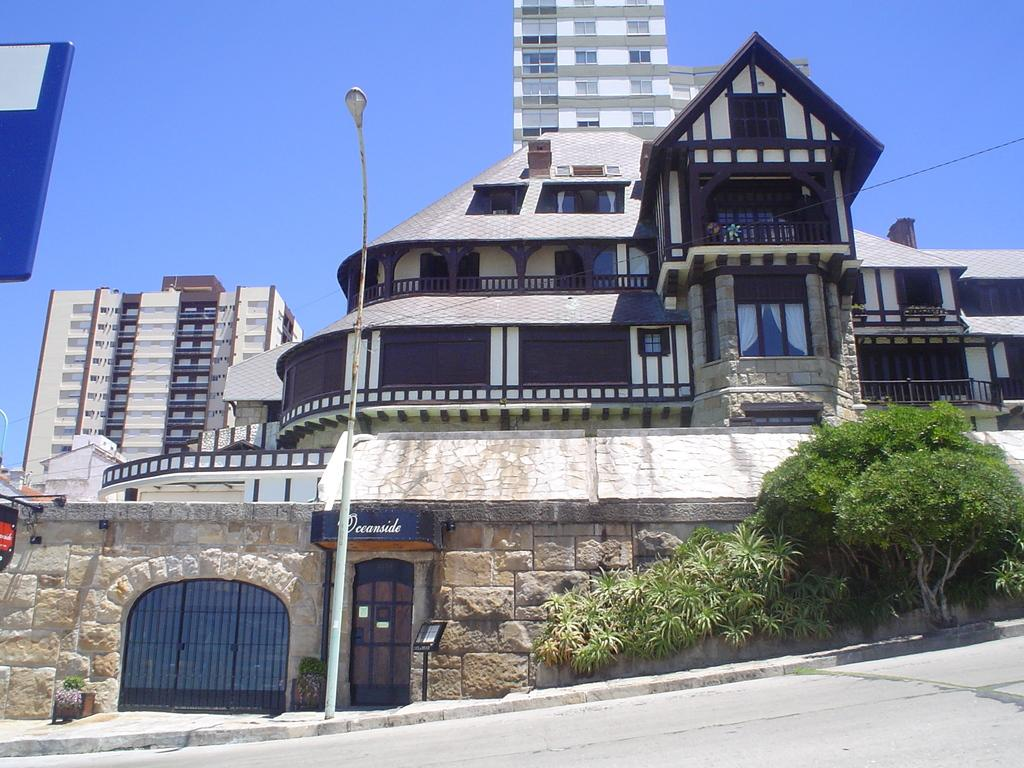What type of structures can be seen in the image? There are buildings in the image. What type of vegetation is present in the image? There are trees in the image. What is the pole and lights used for in the image? The pole and lights are likely used for illumination in the image. What type of advertisements are present in the image? There are hoardings in the image. What type of yoke is being used by the animals in the image? There are no animals or yokes present in the image. What type of veil is covering the buildings in the image? There is no veil covering the buildings in the image; they are visible without any obstruction. What type of crate is being used to transport the trees in the image? There is no crate present in the image, and the trees are not being transported. 